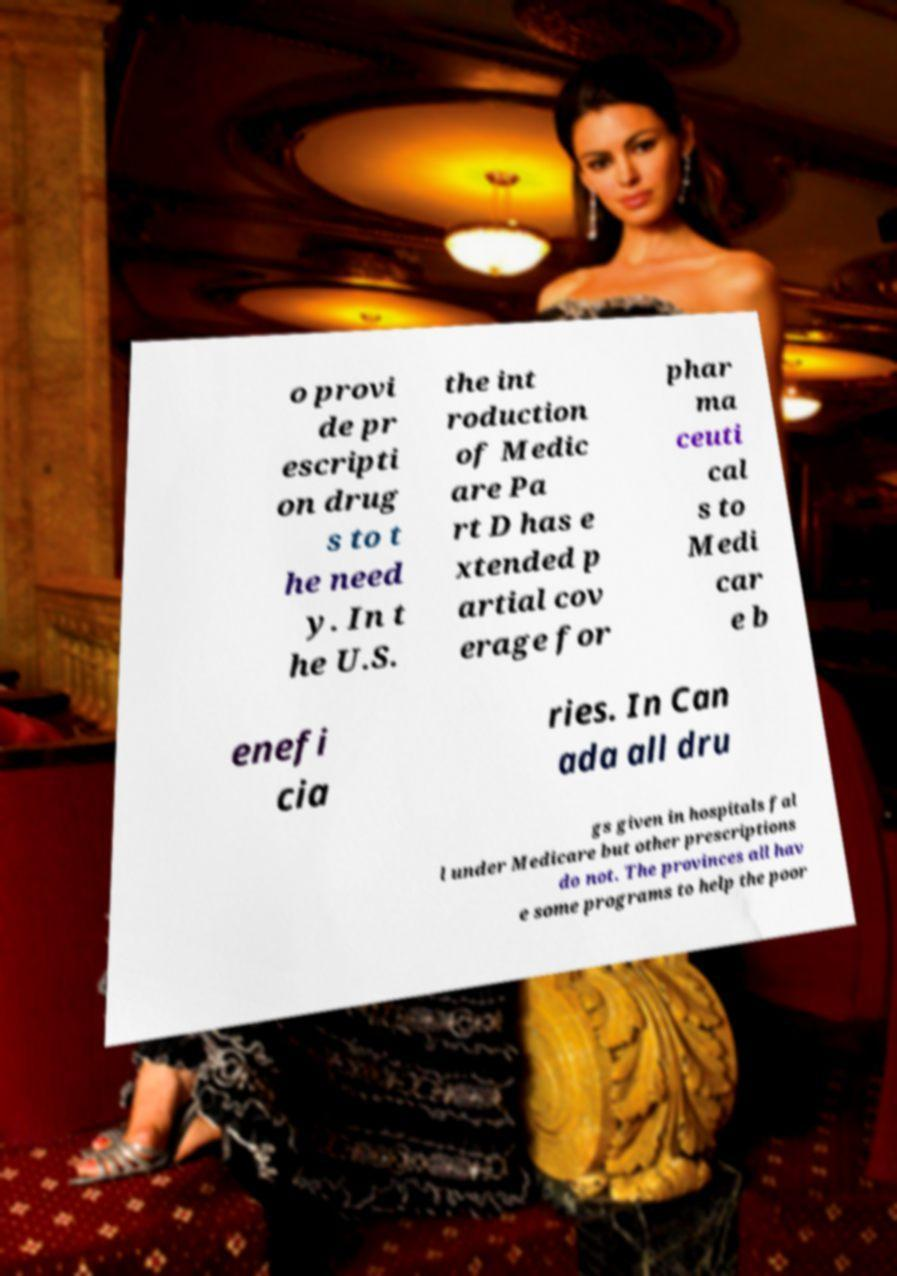Could you extract and type out the text from this image? o provi de pr escripti on drug s to t he need y. In t he U.S. the int roduction of Medic are Pa rt D has e xtended p artial cov erage for phar ma ceuti cal s to Medi car e b enefi cia ries. In Can ada all dru gs given in hospitals fal l under Medicare but other prescriptions do not. The provinces all hav e some programs to help the poor 